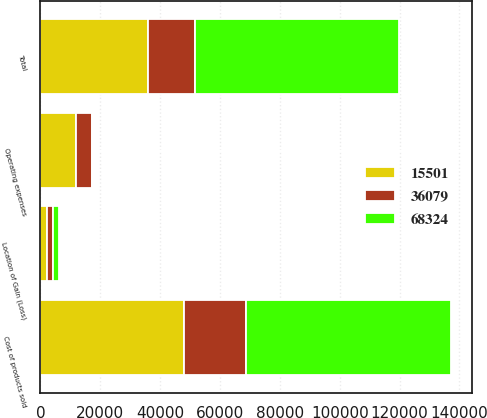Convert chart to OTSL. <chart><loc_0><loc_0><loc_500><loc_500><stacked_bar_chart><ecel><fcel>Location of Gain (Loss)<fcel>Cost of products sold<fcel>Operating expenses<fcel>Total<nl><fcel>15501<fcel>2015<fcel>48082<fcel>12003<fcel>36079<nl><fcel>68324<fcel>2014<fcel>68509<fcel>185<fcel>68324<nl><fcel>36079<fcel>2013<fcel>20751<fcel>5250<fcel>15501<nl></chart> 